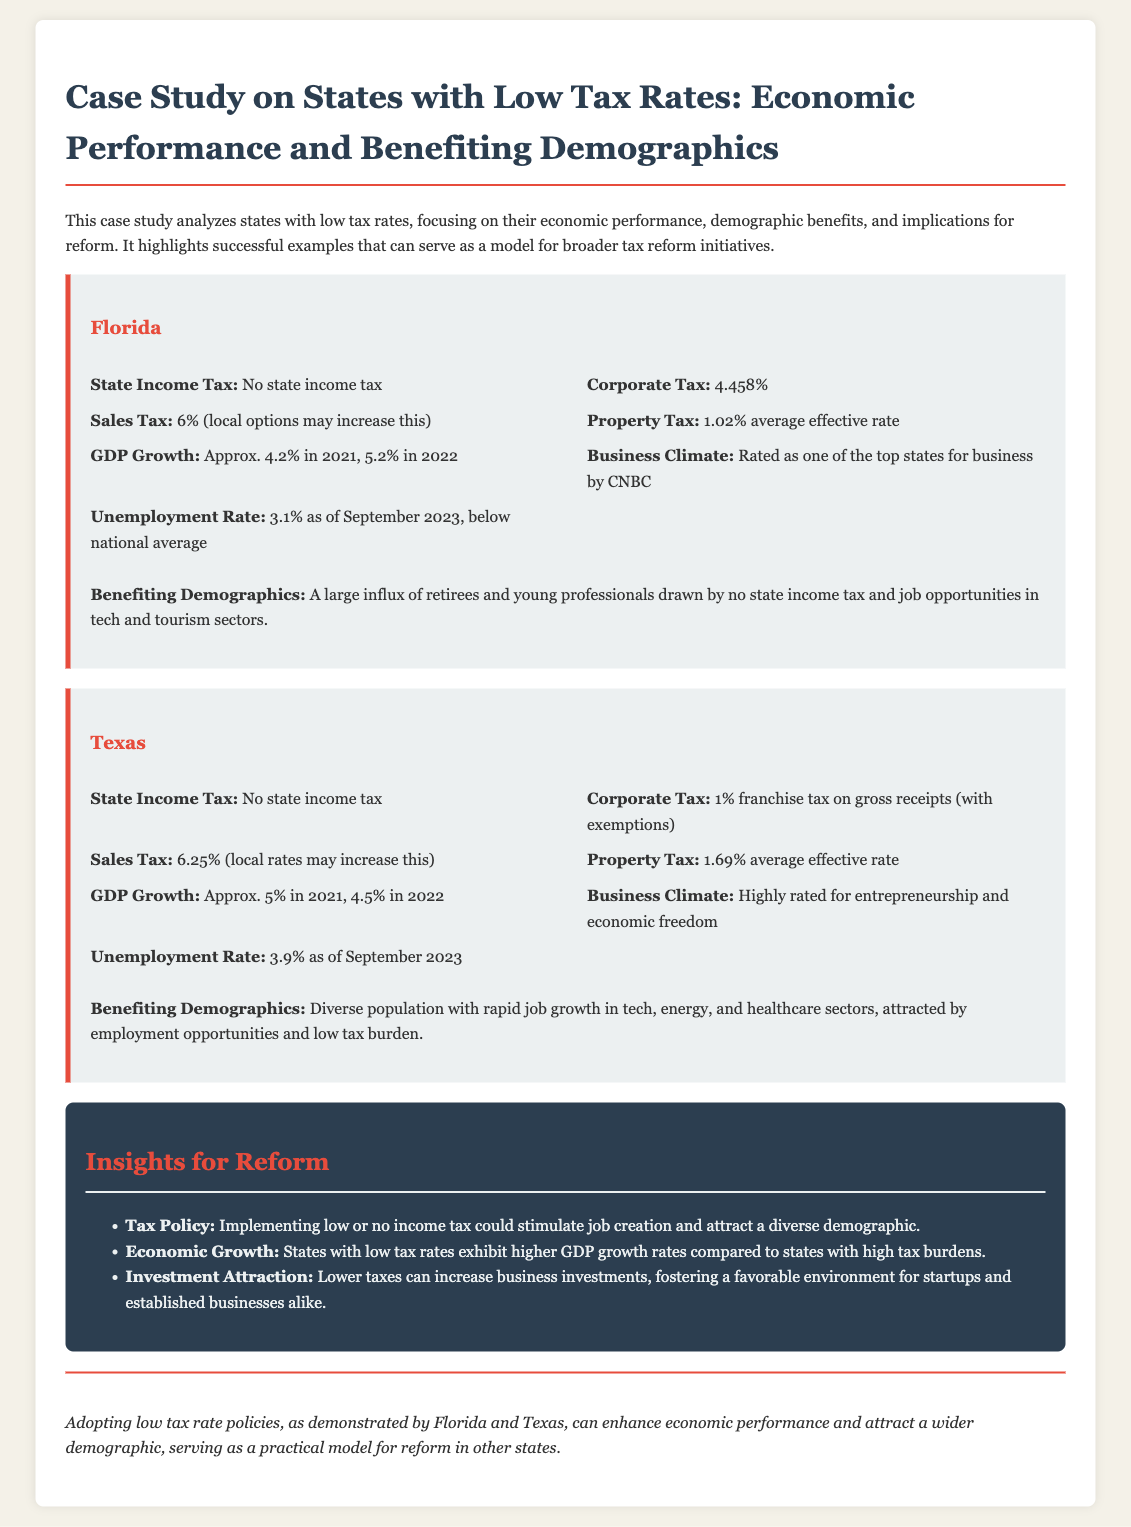What is the state income tax rate in Florida? The state income tax rate in Florida is noted as "No state income tax."
Answer: No state income tax What is Texas's corporate tax rate? The corporate tax rate in Texas is described as a 1% franchise tax on gross receipts.
Answer: 1% franchise tax What was Florida's GDP growth in 2022? Florida's GDP growth in 2022 is stated to be 5.2%.
Answer: 5.2% Which demographic is primarily benefiting from Florida's tax structure? The document mentions that retirees and young professionals are drawn to Florida due to no state income tax and job opportunities.
Answer: Retirees and young professionals How does Texas’s unemployment rate compare to the national average? The document states that Texas has an unemployment rate of 3.9%, which is below the national average.
Answer: Below national average What is cited as a key benefit of implementing low or no income tax? It is indicated that such tax policies could stimulate job creation and attract diverse demographics.
Answer: Stimulate job creation What are the main sectors attracting job growth in Texas? The document highlights that job growth in Texas is rapid in tech, energy, and healthcare sectors.
Answer: Tech, energy, and healthcare What is one insight mentioned for attracting business investments? The document suggests that lower taxes can increase business investments, fostering a favorable environment.
Answer: Increase business investments What is the average effective property tax rate in Florida? The document states that the average effective property tax rate in Florida is 1.02%.
Answer: 1.02% What conclusion is drawn about low tax policies in Florida and Texas? The conclusion states that adopting low tax rate policies can enhance economic performance and attract a wider demographic.
Answer: Enhance economic performance 